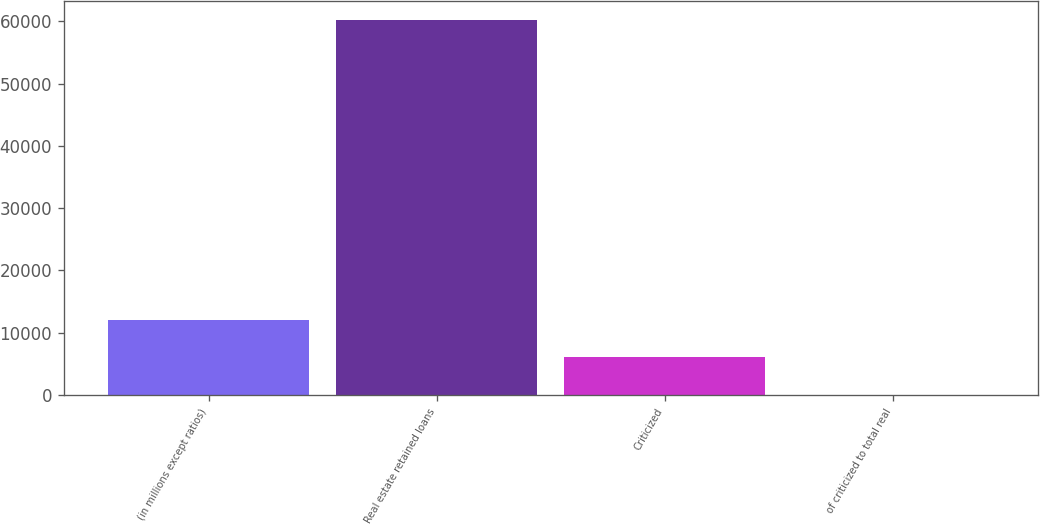Convert chart to OTSL. <chart><loc_0><loc_0><loc_500><loc_500><bar_chart><fcel>(in millions except ratios)<fcel>Real estate retained loans<fcel>Criticized<fcel>of criticized to total real<nl><fcel>12058.7<fcel>60290<fcel>6029.77<fcel>0.86<nl></chart> 